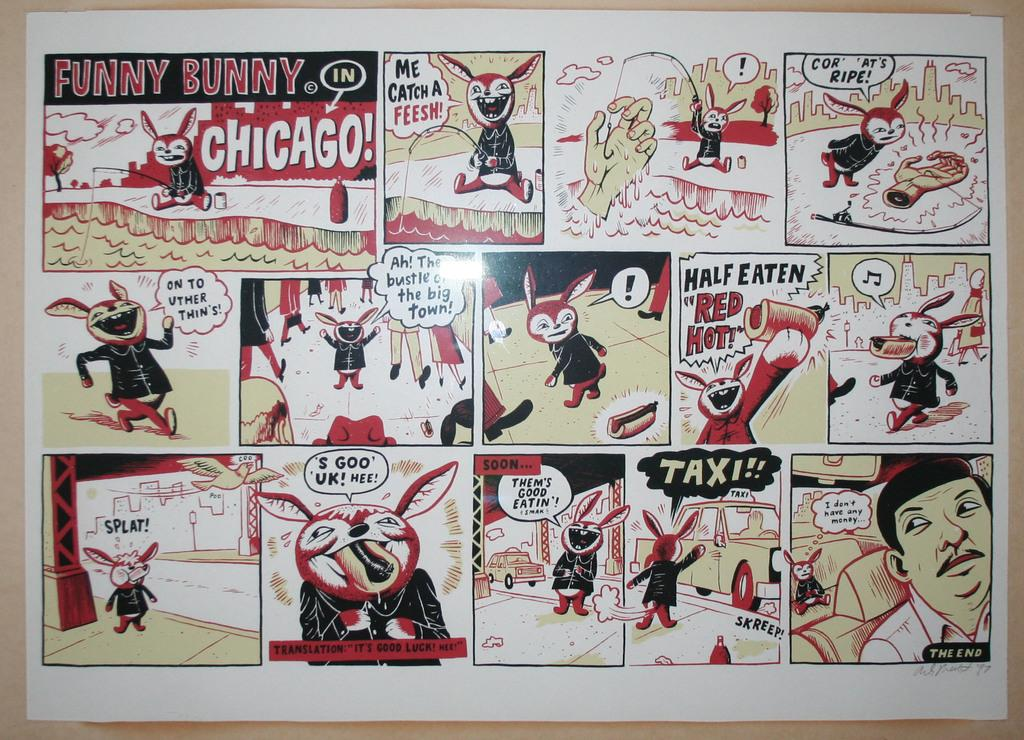<image>
Give a short and clear explanation of the subsequent image. A one page panel comic called Funny Bunny in Chicago. 